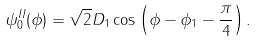<formula> <loc_0><loc_0><loc_500><loc_500>\psi _ { 0 } ^ { I I } ( \phi ) = \sqrt { 2 } D _ { 1 } \cos \left ( \phi - \phi _ { 1 } - \frac { \pi } { 4 } \right ) .</formula> 